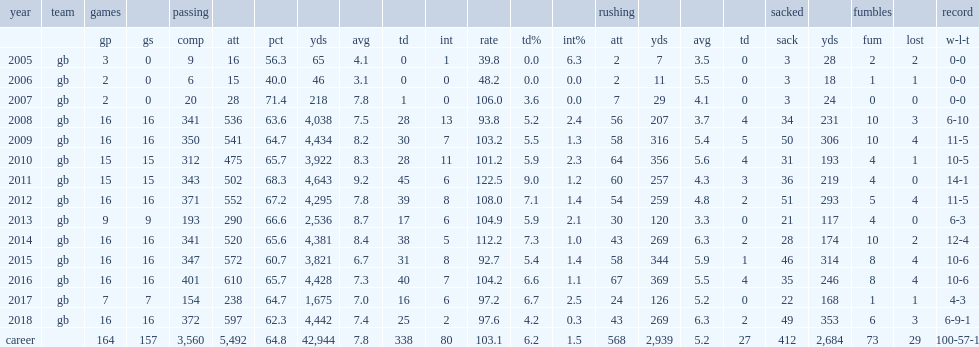What is the highest single-season passer rating for rodgers. 122.5. 